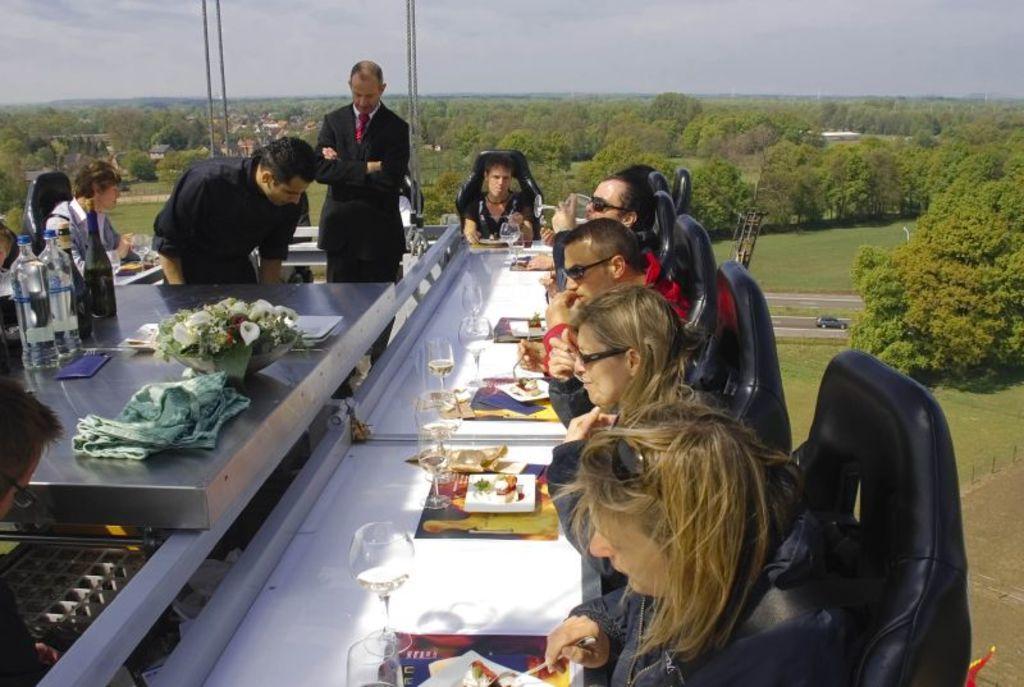Can you describe this image briefly? On the background we can see sky, trees, road , a car and fresh green grass. Here we can see few persons sitting on chairs in front of a table and on the table we can see a plate of food, water glasses, flower bouquet , a towel. we can see two persons standing here near to the table. 